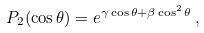Convert formula to latex. <formula><loc_0><loc_0><loc_500><loc_500>P _ { 2 } ( \cos \theta ) = e ^ { \gamma \cos \theta + \beta \cos ^ { 2 } \theta } \, ,</formula> 